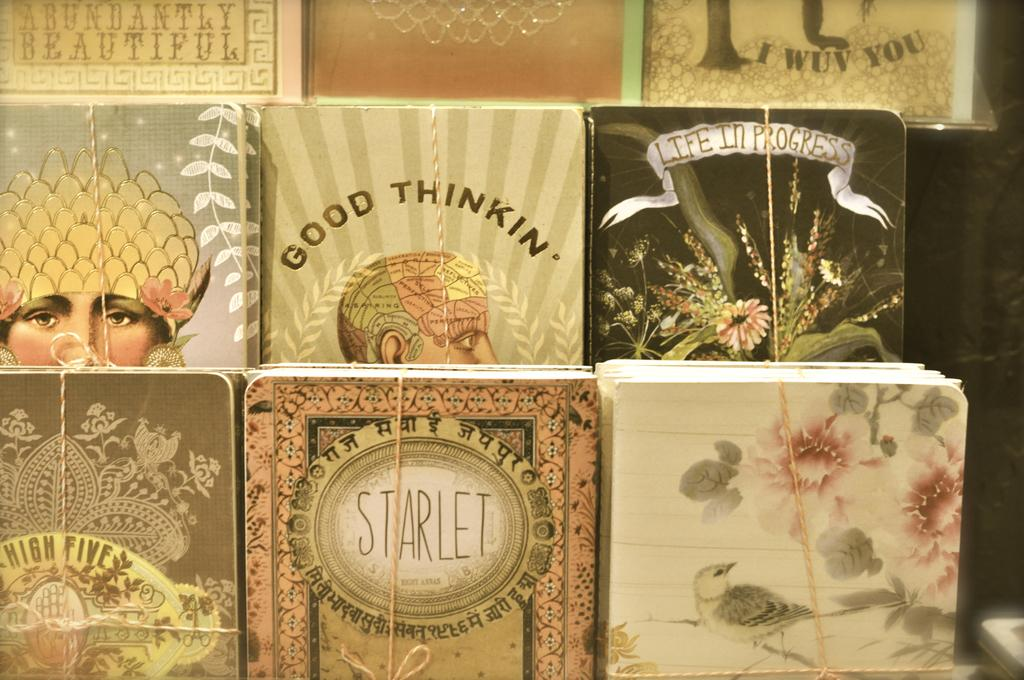What type of objects can be seen in the image? There are different books in the image. Can you describe the books in the image? The image shows various books, but specific details about their titles or subjects cannot be determined from the image alone. How many books are visible in the image? The number of books visible in the image cannot be determined from the provided facts. How many pigs are visible in the image? There are no pigs present in the image; it features different books. What is the governor doing in the image? There is no governor present in the image; it only contains books. 